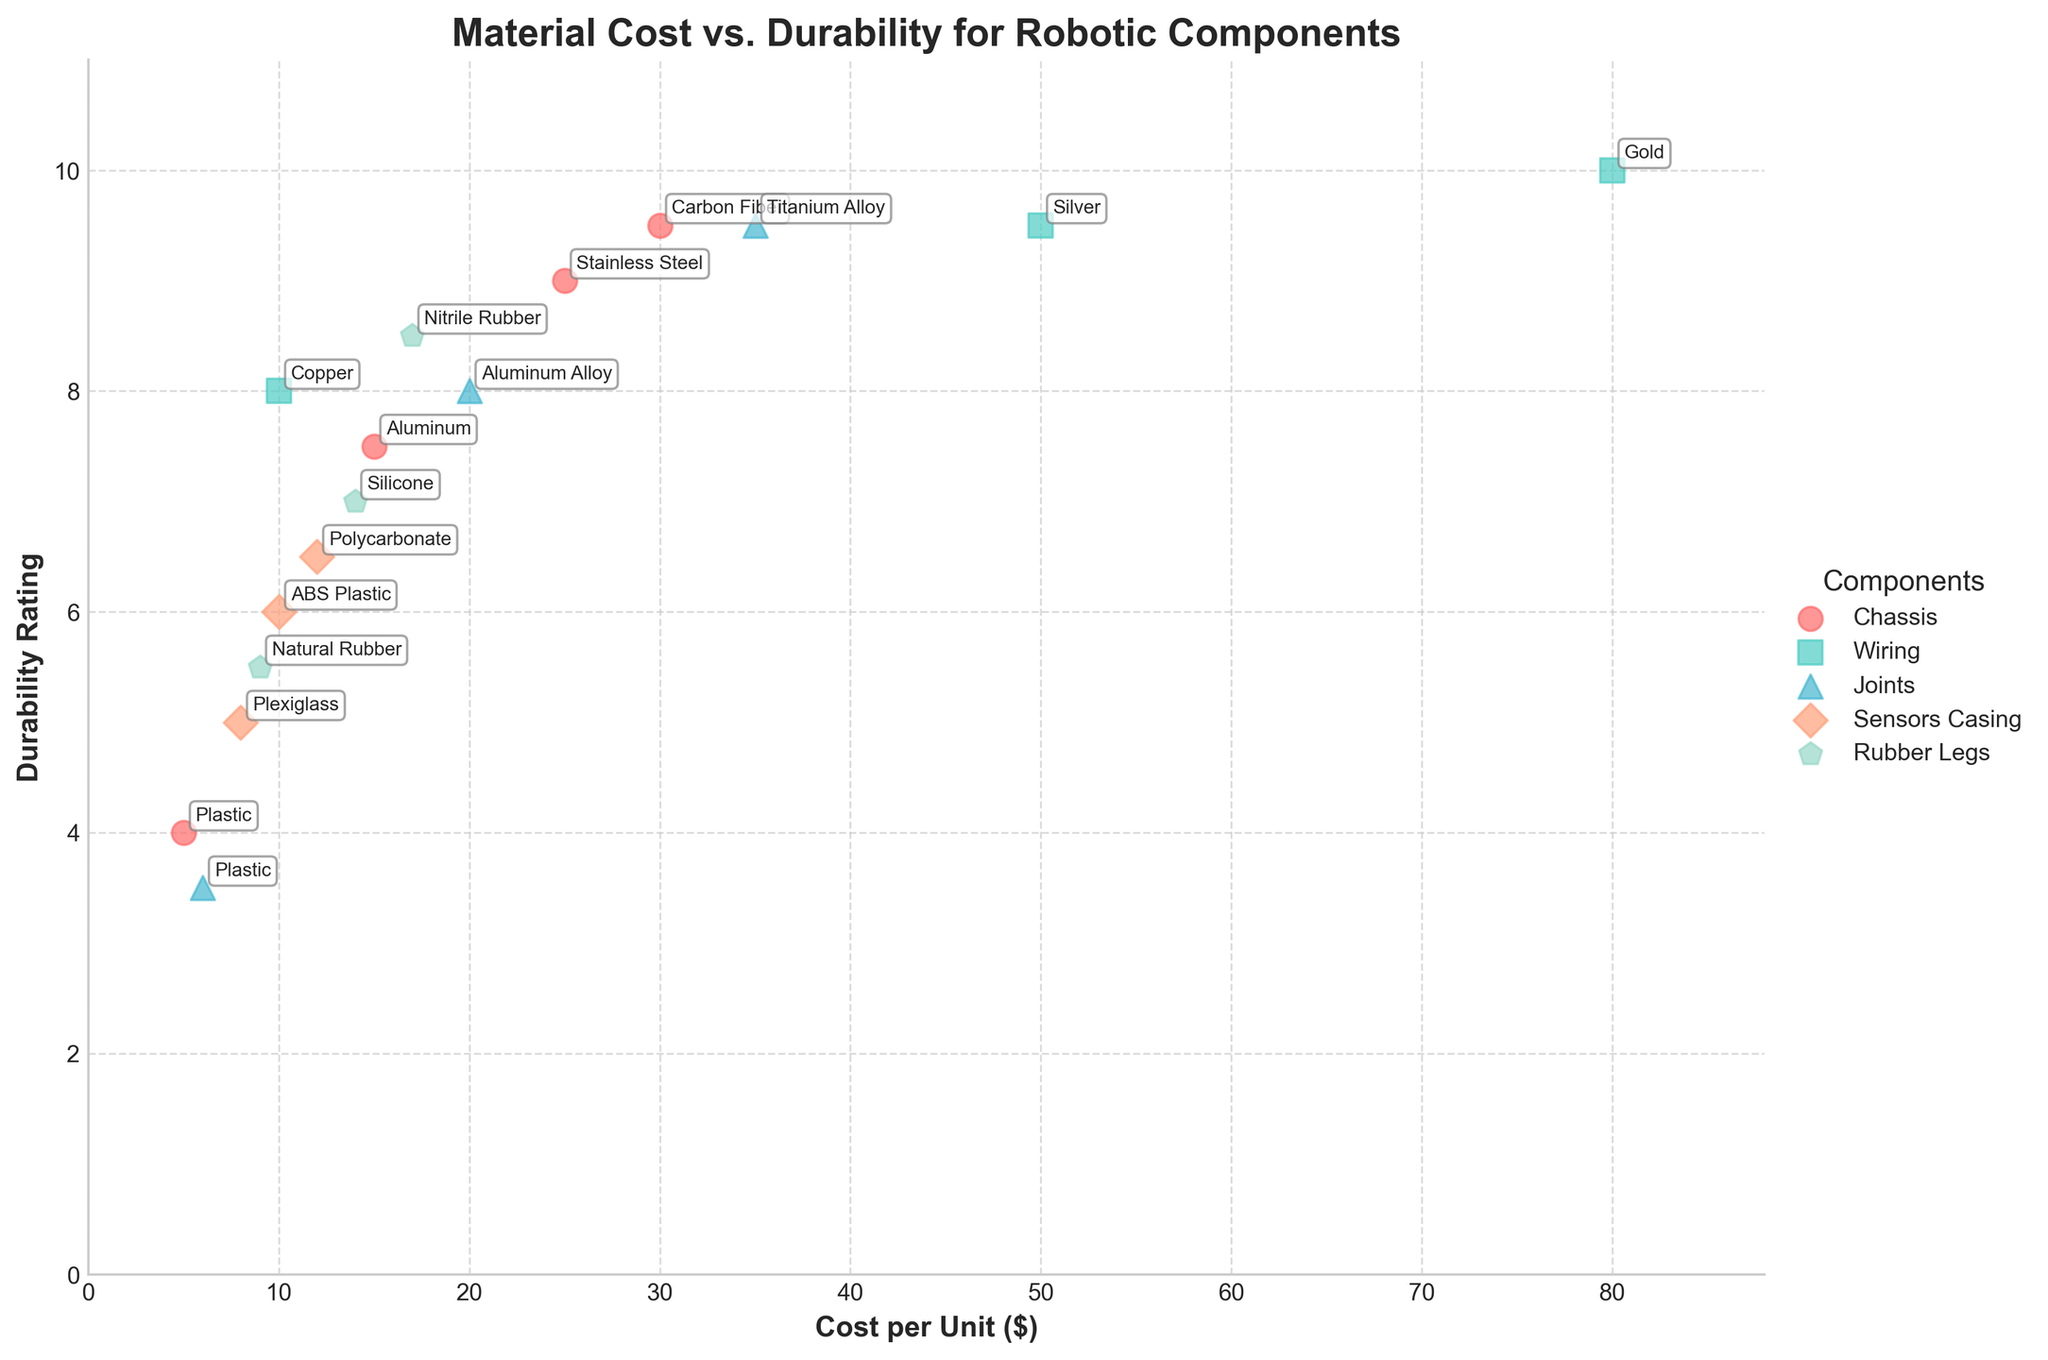What is the title of the scatter plot? The title of a plot is typically found at the top and provides a summary of the information displayed. Here, the title is present at the top of the figure.
Answer: Material Cost vs. Durability for Robotic Components Which component has the highest durability rating? By observing the y-axis, which represents durability rating, and the scatter points in the plot, the component with the highest durability rating is identified by its position closest to the top of the plot.
Answer: Wiring (Gold) How many different components are categorized in the scatter plot? The legend on the right side of the plot indicates the different components by different colors and markers. Counting the unique entries in the legend gives the number of components.
Answer: 5 Which material used for Chassis components is the least durable? Locate the Chassis component points on the plot (indicated by a consistent color and marker) and find the point with the lowest y-axis value, which represents durability rating.
Answer: Plastic What is the relationship between the cost per unit and durability for Aluminum? Find the points labeled Aluminum on the scatter plot and observe their position on the x-axis (cost per unit) and y-axis (durability).
Answer: Chassis (Cost: $15, Durability: 7.5) Which component has the least variation in durability ratings? Identify the component with the smallest spread of points along the y-axis. The smaller the vertical spread, the less variation in durability ratings.
Answer: Sensors Casing How does the durability of Gold compare to Silver in Wiring? Locate the points for Gold and Silver within Wiring on the plot and compare their y-axis positions. Gold's point is further up the y-axis if it is more durable and lower if less.
Answer: Gold has higher durability than Silver What is the average durability rating for Sensor Casing materials? Identify the points representing Sensor Casing on the plot, note their y-axis values (durability ratings), and calculate the average. Polycarbonate (6.5), Plexiglass (5), ABS Plastic (6). Average = (6.5 + 5 + 6) / 3.
Answer: 5.83 Which material among Joints has the highest cost per unit? Find the Joints component points on the plot and identify which has the farthest rightward position on the x-axis, indicating the highest cost per unit.
Answer: Titanium Alloy What's the cost and durability of the most cost-effective Rubber Legs material? Compare costs and durability ratings for materials labeled under Rubber Legs. Recognize the material with the lowest cost while maintaining a relatively high durability rating.
Answer: Natural Rubber (Cost: $9, Durability: 5.5) 